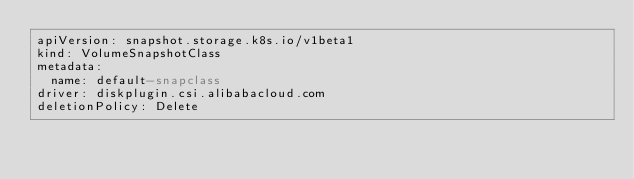Convert code to text. <code><loc_0><loc_0><loc_500><loc_500><_YAML_>apiVersion: snapshot.storage.k8s.io/v1beta1
kind: VolumeSnapshotClass
metadata:
  name: default-snapclass
driver: diskplugin.csi.alibabacloud.com
deletionPolicy: Delete</code> 